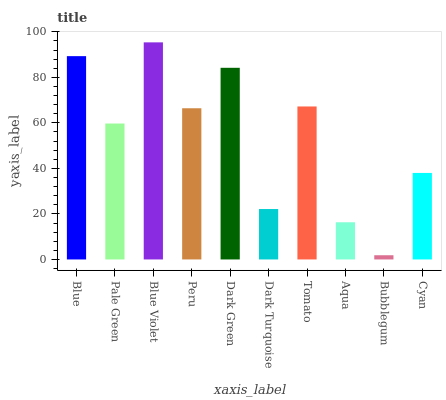Is Bubblegum the minimum?
Answer yes or no. Yes. Is Blue Violet the maximum?
Answer yes or no. Yes. Is Pale Green the minimum?
Answer yes or no. No. Is Pale Green the maximum?
Answer yes or no. No. Is Blue greater than Pale Green?
Answer yes or no. Yes. Is Pale Green less than Blue?
Answer yes or no. Yes. Is Pale Green greater than Blue?
Answer yes or no. No. Is Blue less than Pale Green?
Answer yes or no. No. Is Peru the high median?
Answer yes or no. Yes. Is Pale Green the low median?
Answer yes or no. Yes. Is Bubblegum the high median?
Answer yes or no. No. Is Blue Violet the low median?
Answer yes or no. No. 